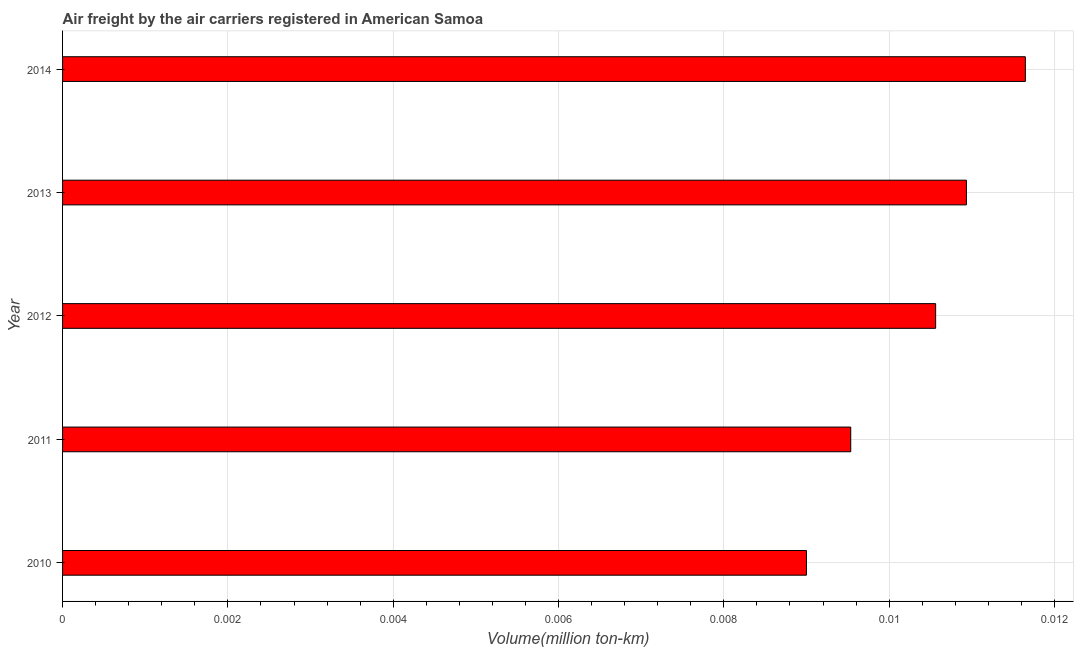Does the graph contain grids?
Make the answer very short. Yes. What is the title of the graph?
Your response must be concise. Air freight by the air carriers registered in American Samoa. What is the label or title of the X-axis?
Provide a short and direct response. Volume(million ton-km). What is the air freight in 2013?
Your answer should be compact. 0.01. Across all years, what is the maximum air freight?
Make the answer very short. 0.01. Across all years, what is the minimum air freight?
Offer a terse response. 0.01. What is the sum of the air freight?
Ensure brevity in your answer.  0.05. What is the difference between the air freight in 2010 and 2013?
Ensure brevity in your answer.  -0. What is the average air freight per year?
Provide a succinct answer. 0.01. What is the median air freight?
Keep it short and to the point. 0.01. In how many years, is the air freight greater than 0.0116 million ton-km?
Keep it short and to the point. 1. What is the ratio of the air freight in 2011 to that in 2013?
Give a very brief answer. 0.87. What is the difference between the highest and the lowest air freight?
Your answer should be compact. 0. In how many years, is the air freight greater than the average air freight taken over all years?
Provide a succinct answer. 3. How many bars are there?
Your answer should be compact. 5. How many years are there in the graph?
Provide a short and direct response. 5. What is the difference between two consecutive major ticks on the X-axis?
Give a very brief answer. 0. What is the Volume(million ton-km) of 2010?
Ensure brevity in your answer.  0.01. What is the Volume(million ton-km) in 2011?
Make the answer very short. 0.01. What is the Volume(million ton-km) of 2012?
Offer a very short reply. 0.01. What is the Volume(million ton-km) in 2013?
Provide a short and direct response. 0.01. What is the Volume(million ton-km) of 2014?
Ensure brevity in your answer.  0.01. What is the difference between the Volume(million ton-km) in 2010 and 2011?
Your answer should be compact. -0. What is the difference between the Volume(million ton-km) in 2010 and 2012?
Your answer should be very brief. -0. What is the difference between the Volume(million ton-km) in 2010 and 2013?
Your answer should be compact. -0. What is the difference between the Volume(million ton-km) in 2010 and 2014?
Ensure brevity in your answer.  -0. What is the difference between the Volume(million ton-km) in 2011 and 2012?
Keep it short and to the point. -0. What is the difference between the Volume(million ton-km) in 2011 and 2013?
Offer a terse response. -0. What is the difference between the Volume(million ton-km) in 2011 and 2014?
Provide a succinct answer. -0. What is the difference between the Volume(million ton-km) in 2012 and 2013?
Make the answer very short. -0. What is the difference between the Volume(million ton-km) in 2012 and 2014?
Make the answer very short. -0. What is the difference between the Volume(million ton-km) in 2013 and 2014?
Keep it short and to the point. -0. What is the ratio of the Volume(million ton-km) in 2010 to that in 2011?
Your response must be concise. 0.94. What is the ratio of the Volume(million ton-km) in 2010 to that in 2012?
Your answer should be compact. 0.85. What is the ratio of the Volume(million ton-km) in 2010 to that in 2013?
Give a very brief answer. 0.82. What is the ratio of the Volume(million ton-km) in 2010 to that in 2014?
Provide a short and direct response. 0.77. What is the ratio of the Volume(million ton-km) in 2011 to that in 2012?
Provide a short and direct response. 0.9. What is the ratio of the Volume(million ton-km) in 2011 to that in 2013?
Make the answer very short. 0.87. What is the ratio of the Volume(million ton-km) in 2011 to that in 2014?
Ensure brevity in your answer.  0.82. What is the ratio of the Volume(million ton-km) in 2012 to that in 2014?
Offer a terse response. 0.91. What is the ratio of the Volume(million ton-km) in 2013 to that in 2014?
Your answer should be compact. 0.94. 